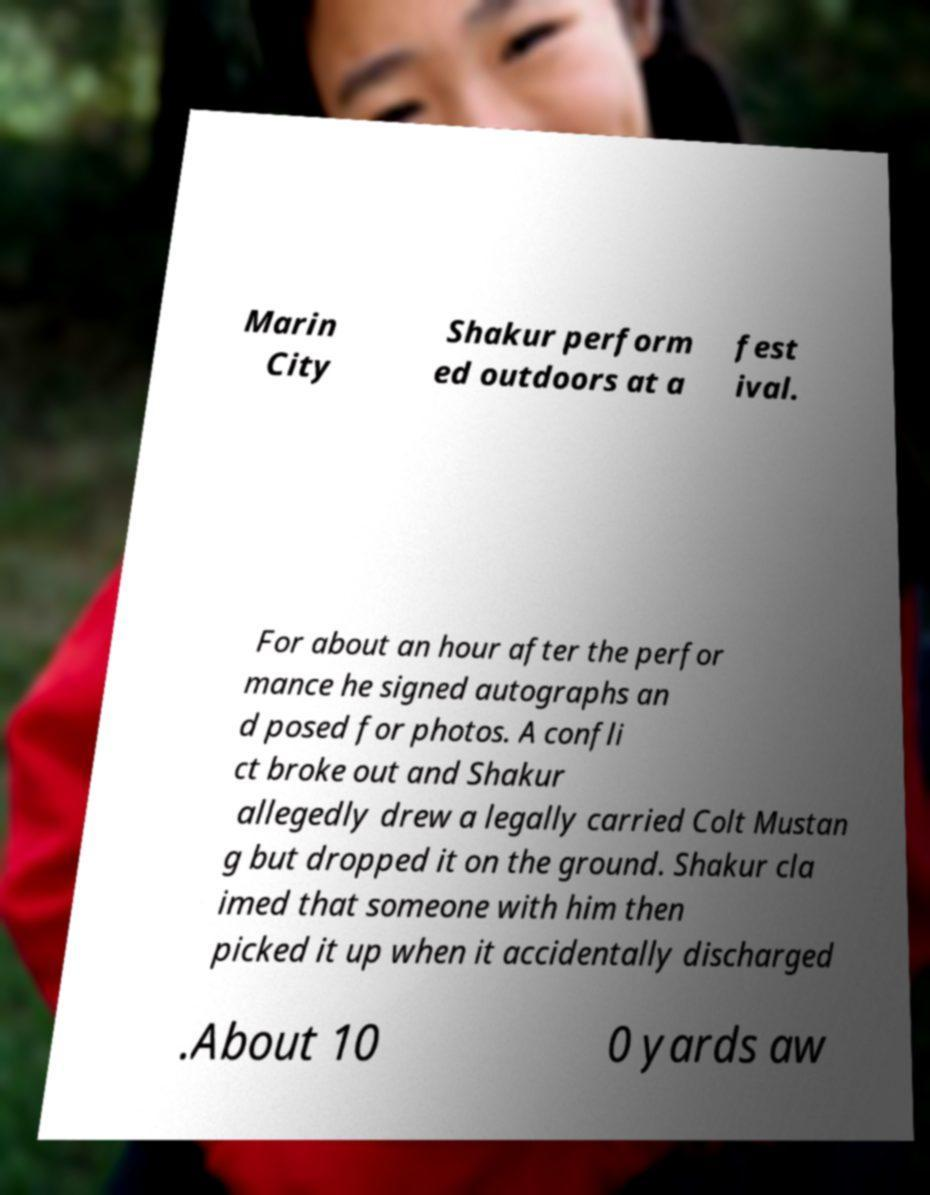For documentation purposes, I need the text within this image transcribed. Could you provide that? Marin City Shakur perform ed outdoors at a fest ival. For about an hour after the perfor mance he signed autographs an d posed for photos. A confli ct broke out and Shakur allegedly drew a legally carried Colt Mustan g but dropped it on the ground. Shakur cla imed that someone with him then picked it up when it accidentally discharged .About 10 0 yards aw 